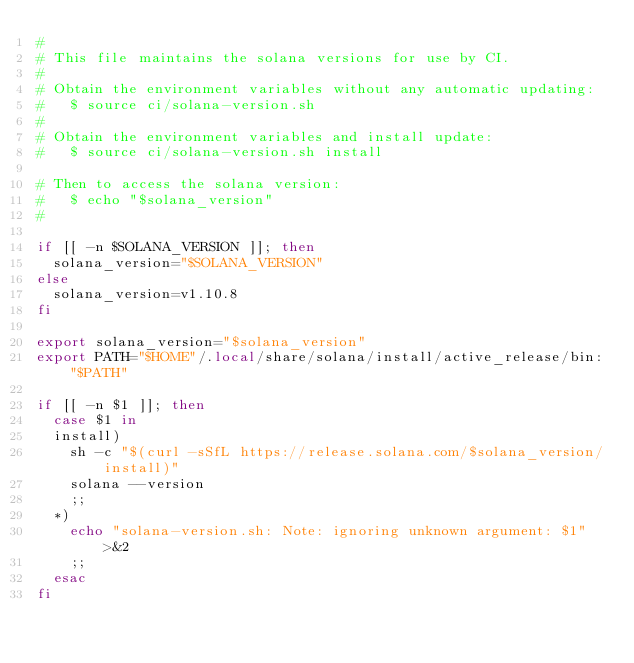Convert code to text. <code><loc_0><loc_0><loc_500><loc_500><_Bash_>#
# This file maintains the solana versions for use by CI.
#
# Obtain the environment variables without any automatic updating:
#   $ source ci/solana-version.sh
#
# Obtain the environment variables and install update:
#   $ source ci/solana-version.sh install

# Then to access the solana version:
#   $ echo "$solana_version"
#

if [[ -n $SOLANA_VERSION ]]; then
  solana_version="$SOLANA_VERSION"
else
  solana_version=v1.10.8
fi

export solana_version="$solana_version"
export PATH="$HOME"/.local/share/solana/install/active_release/bin:"$PATH"

if [[ -n $1 ]]; then
  case $1 in
  install)
    sh -c "$(curl -sSfL https://release.solana.com/$solana_version/install)"
    solana --version
    ;;
  *)
    echo "solana-version.sh: Note: ignoring unknown argument: $1" >&2
    ;;
  esac
fi
</code> 